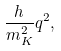Convert formula to latex. <formula><loc_0><loc_0><loc_500><loc_500>\frac { h } { m _ { K } ^ { 2 } } q ^ { 2 } ,</formula> 